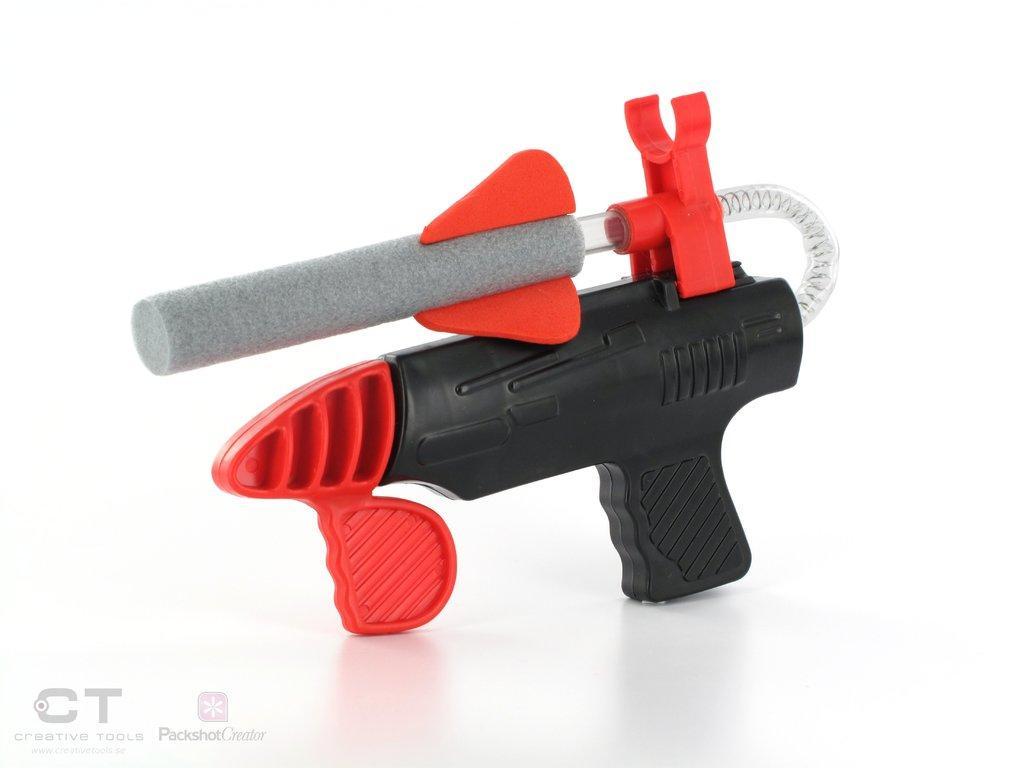In one or two sentences, can you explain what this image depicts? In this picture we can see a toy. 